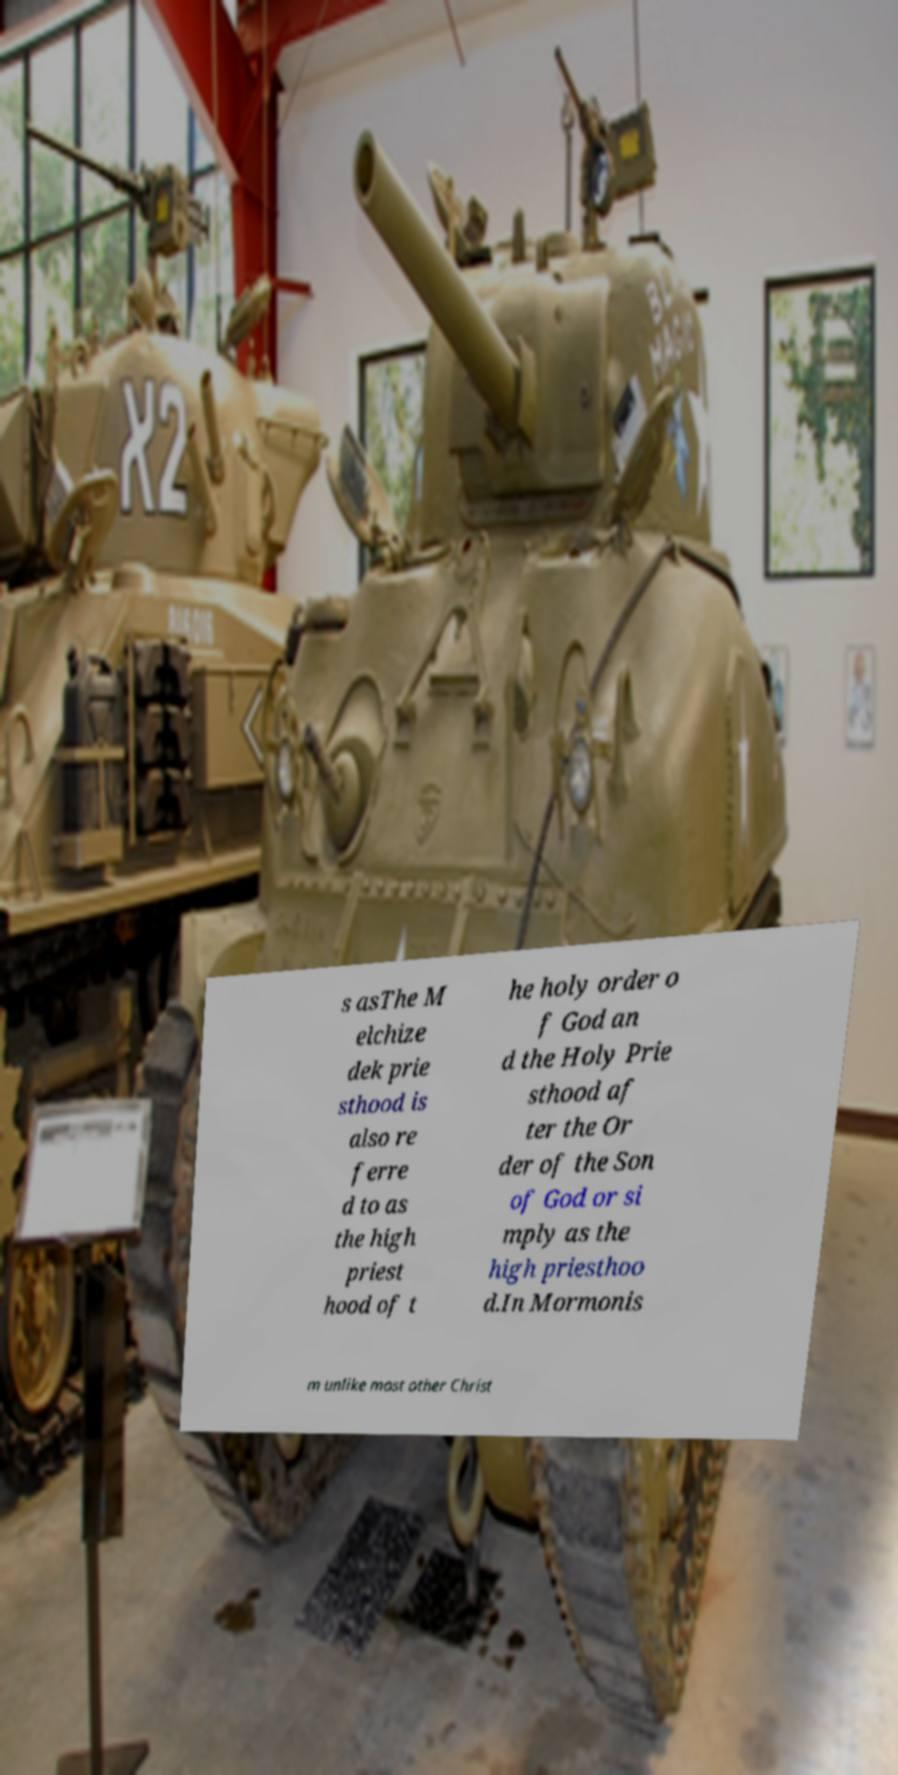Please read and relay the text visible in this image. What does it say? s asThe M elchize dek prie sthood is also re ferre d to as the high priest hood of t he holy order o f God an d the Holy Prie sthood af ter the Or der of the Son of God or si mply as the high priesthoo d.In Mormonis m unlike most other Christ 